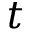Convert formula to latex. <formula><loc_0><loc_0><loc_500><loc_500>t</formula> 